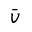Convert formula to latex. <formula><loc_0><loc_0><loc_500><loc_500>\bar { v }</formula> 